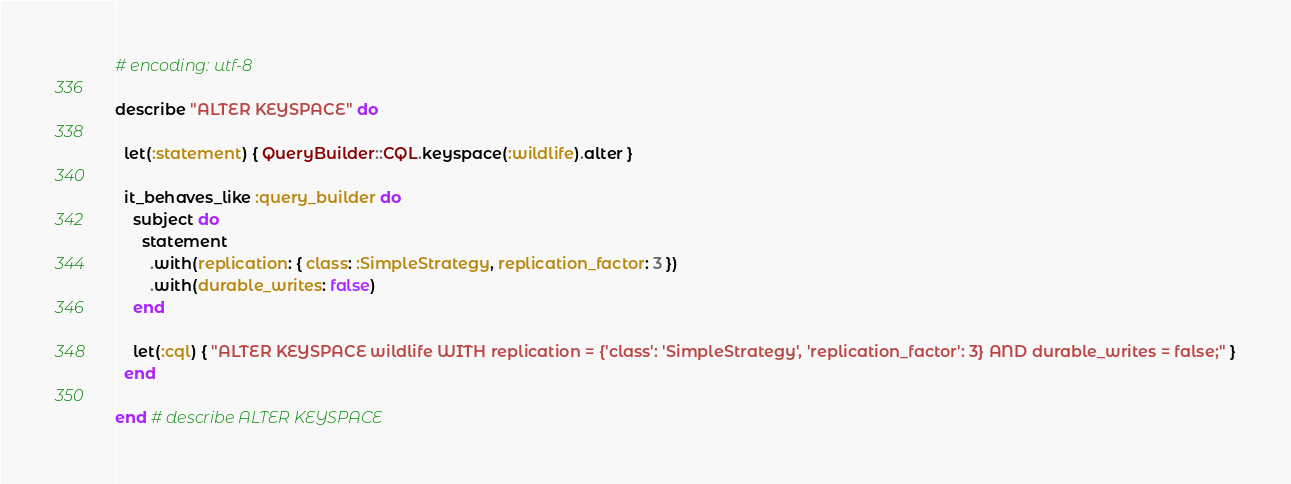Convert code to text. <code><loc_0><loc_0><loc_500><loc_500><_Ruby_># encoding: utf-8

describe "ALTER KEYSPACE" do

  let(:statement) { QueryBuilder::CQL.keyspace(:wildlife).alter }

  it_behaves_like :query_builder do
    subject do
      statement
        .with(replication: { class: :SimpleStrategy, replication_factor: 3 })
        .with(durable_writes: false)
    end

    let(:cql) { "ALTER KEYSPACE wildlife WITH replication = {'class': 'SimpleStrategy', 'replication_factor': 3} AND durable_writes = false;" }
  end

end # describe ALTER KEYSPACE
</code> 